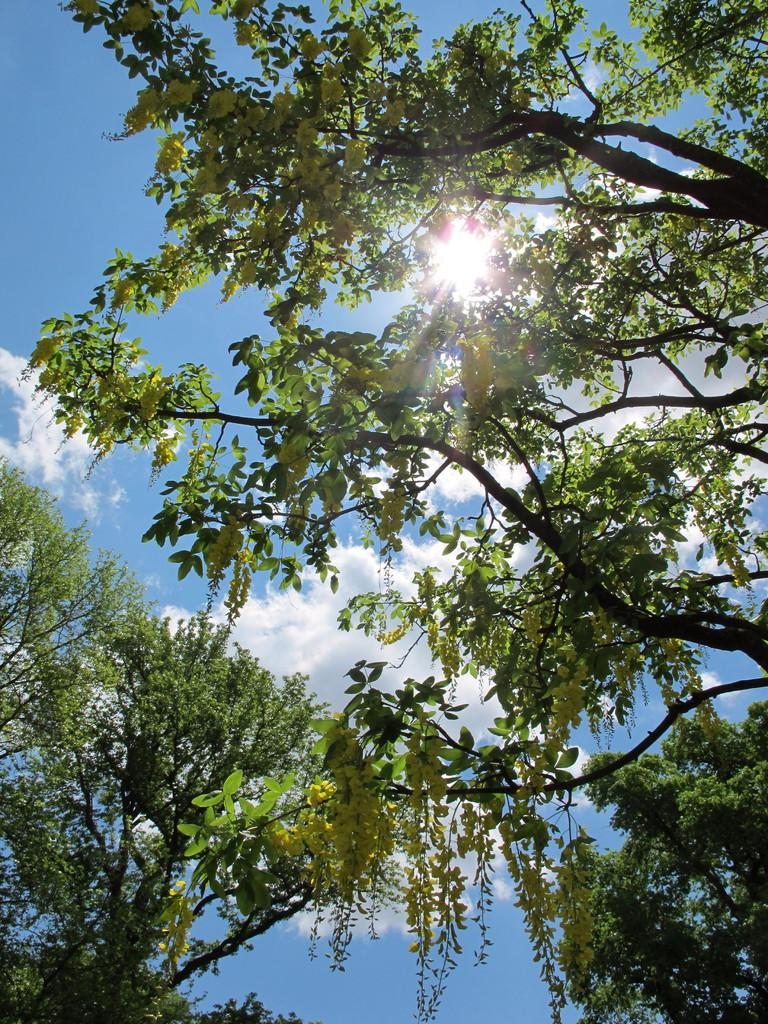What is the setting of the image? The image has an outside view. What can be seen in the foreground of the image? There are trees in the foreground of the image. What is visible in the background of the image? The sky is visible in the background of the image. What type of sugar is being used to treat the tree in the image? There is no tree being treated with sugar in the image; it features trees in the foreground and the sky in the background. 